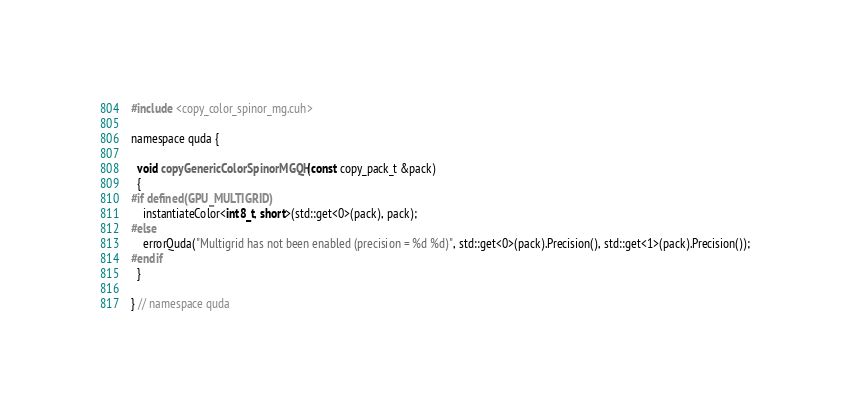Convert code to text. <code><loc_0><loc_0><loc_500><loc_500><_Cuda_>#include <copy_color_spinor_mg.cuh>

namespace quda {
  
  void copyGenericColorSpinorMGQH(const copy_pack_t &pack)
  {
#if defined(GPU_MULTIGRID)
    instantiateColor<int8_t, short>(std::get<0>(pack), pack);
#else
    errorQuda("Multigrid has not been enabled (precision = %d %d)", std::get<0>(pack).Precision(), std::get<1>(pack).Precision());
#endif
  }

} // namespace quda
</code> 